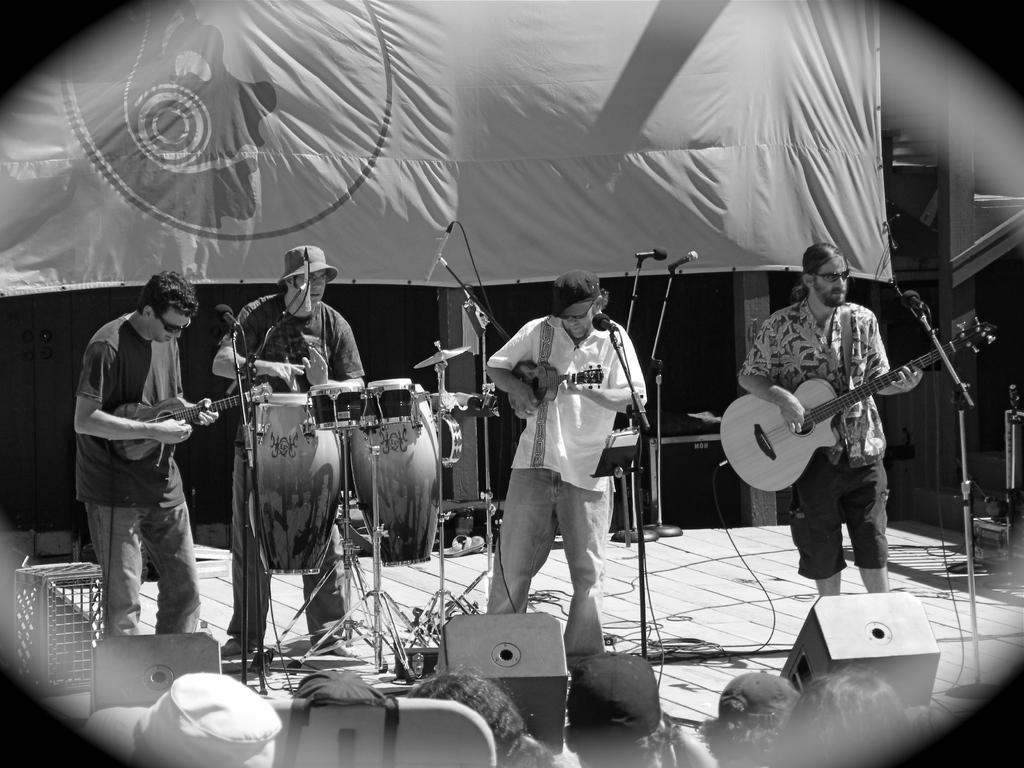What are the people in the image doing? The people in the image are playing musical instruments. Can you identify the specific instruments being played? Yes, one person is playing the guitar, and another person is playing the drums. Where are the musicians located in the image? The musicians are on a stage. What can be seen in the background of the image? There is a banner in the background of the image. How many tests are being conducted on the baby in the image? There is no baby present in the image, and therefore no tests are being conducted. Can you describe the veins visible on the baby's hand in the image? There is no baby present in the image, and thus no veins can be observed. 